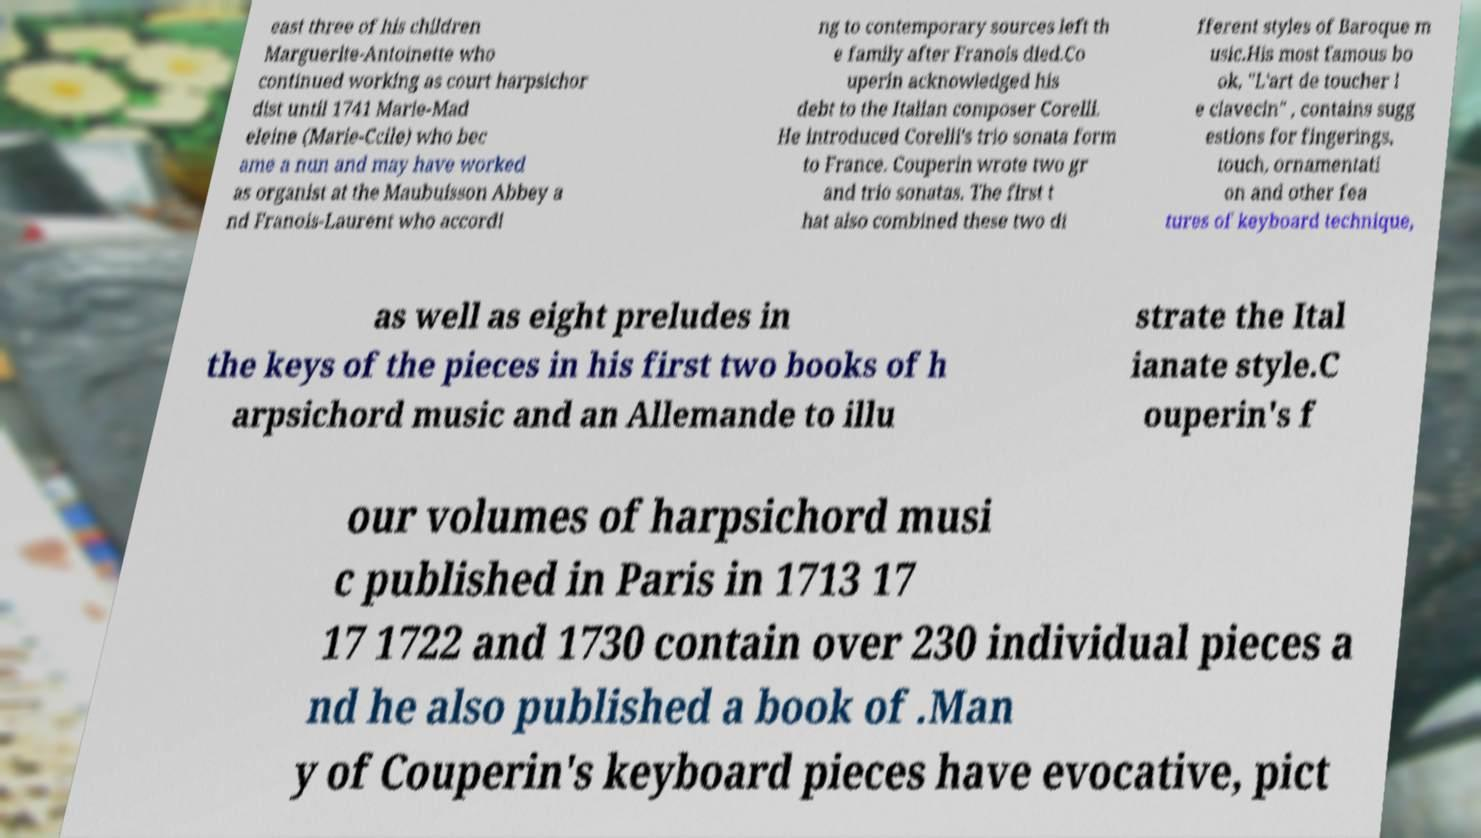There's text embedded in this image that I need extracted. Can you transcribe it verbatim? east three of his children Marguerite-Antoinette who continued working as court harpsichor dist until 1741 Marie-Mad eleine (Marie-Ccile) who bec ame a nun and may have worked as organist at the Maubuisson Abbey a nd Franois-Laurent who accordi ng to contemporary sources left th e family after Franois died.Co uperin acknowledged his debt to the Italian composer Corelli. He introduced Corelli's trio sonata form to France. Couperin wrote two gr and trio sonatas. The first t hat also combined these two di fferent styles of Baroque m usic.His most famous bo ok, "L'art de toucher l e clavecin" , contains sugg estions for fingerings, touch, ornamentati on and other fea tures of keyboard technique, as well as eight preludes in the keys of the pieces in his first two books of h arpsichord music and an Allemande to illu strate the Ital ianate style.C ouperin's f our volumes of harpsichord musi c published in Paris in 1713 17 17 1722 and 1730 contain over 230 individual pieces a nd he also published a book of .Man y of Couperin's keyboard pieces have evocative, pict 